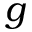Convert formula to latex. <formula><loc_0><loc_0><loc_500><loc_500>g</formula> 